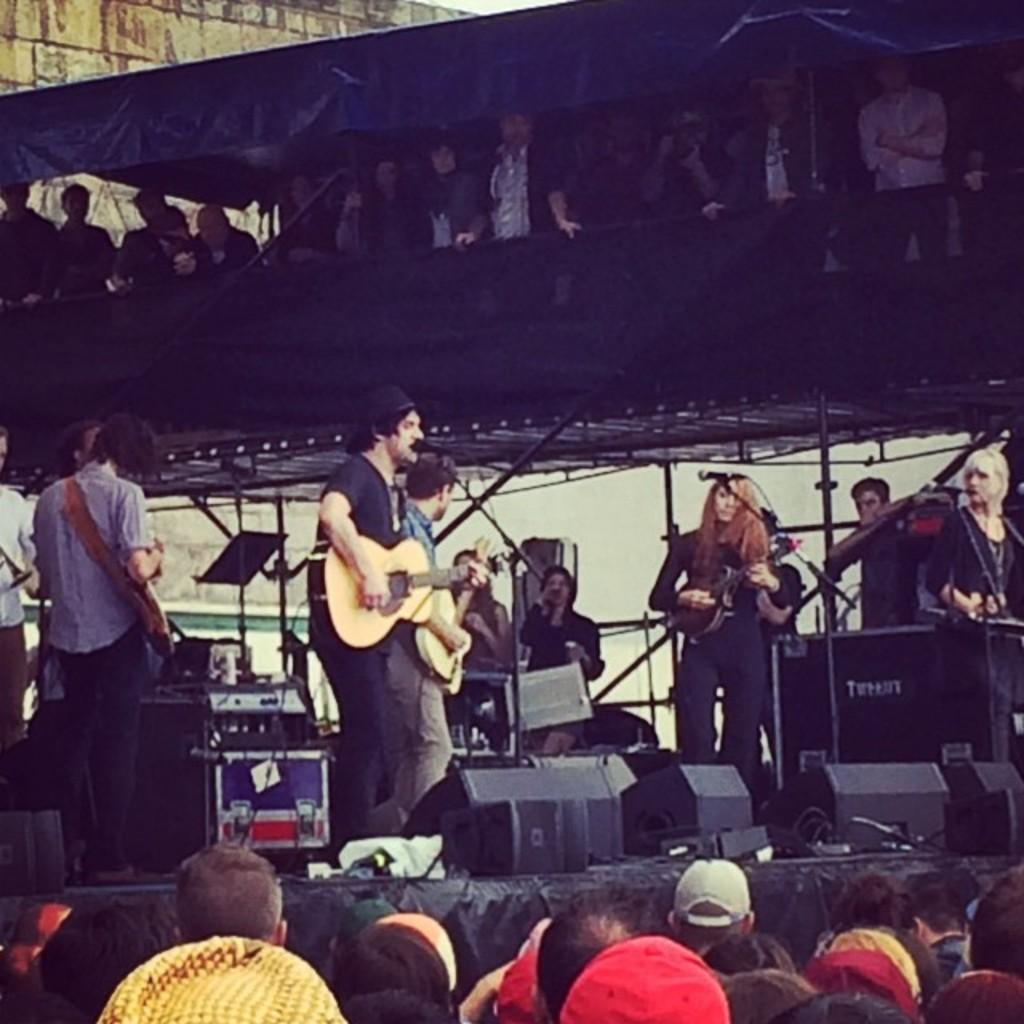How many people are in the image? There is a group of people in the image. What are the people on the stage doing? The people on the stage are playing guitar. What equipment is present in the image for amplifying sound? There are speakers and microphones in the image. What type of wires can be seen in the image? There are wires in the image. What objects are on the stage besides the people and musical equipment? There are boxes on the stage. How many houses can be seen in the image? There are no houses present in the image. What type of tool is being used by the guitarists in the image? The guitarists are using guitars, not a wrench, in the image. 